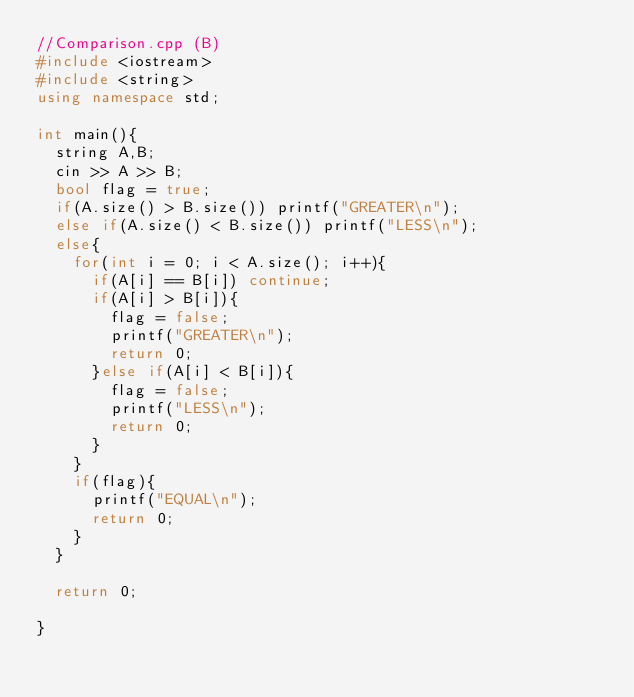<code> <loc_0><loc_0><loc_500><loc_500><_C++_>//Comparison.cpp (B)
#include <iostream>
#include <string>
using namespace std;

int main(){
  string A,B;
  cin >> A >> B;
  bool flag = true;
  if(A.size() > B.size()) printf("GREATER\n");
  else if(A.size() < B.size()) printf("LESS\n");
  else{
    for(int i = 0; i < A.size(); i++){
      if(A[i] == B[i]) continue;
      if(A[i] > B[i]){
        flag = false;
        printf("GREATER\n");
        return 0;
      }else if(A[i] < B[i]){
        flag = false;
        printf("LESS\n");
        return 0;
      }
    }
    if(flag){
      printf("EQUAL\n");
      return 0;
    }
  }

  return 0;

}
</code> 